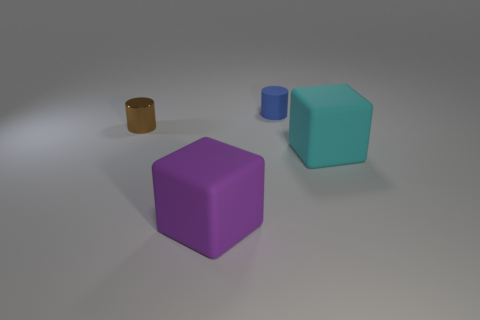Add 4 large brown objects. How many objects exist? 8 Subtract 2 cylinders. How many cylinders are left? 0 Subtract all purple blocks. How many blocks are left? 1 Subtract all green metallic cubes. Subtract all big purple rubber blocks. How many objects are left? 3 Add 2 purple things. How many purple things are left? 3 Add 3 big things. How many big things exist? 5 Subtract 1 brown cylinders. How many objects are left? 3 Subtract all brown cylinders. Subtract all green balls. How many cylinders are left? 1 Subtract all green cylinders. How many purple cubes are left? 1 